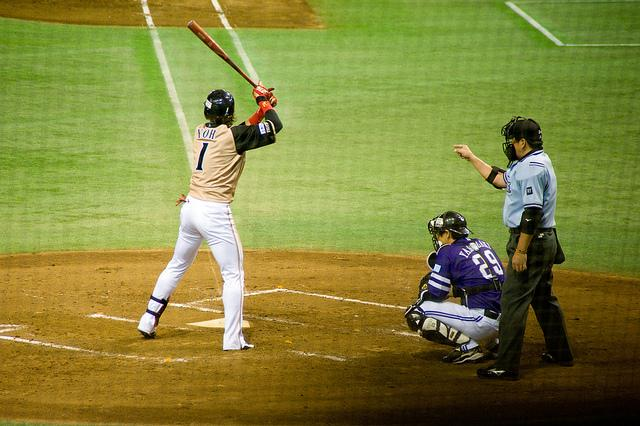Why is the guy in purple crouching? Please explain your reasoning. catcher's stance. The man has his mitt ready to catch the ball. 